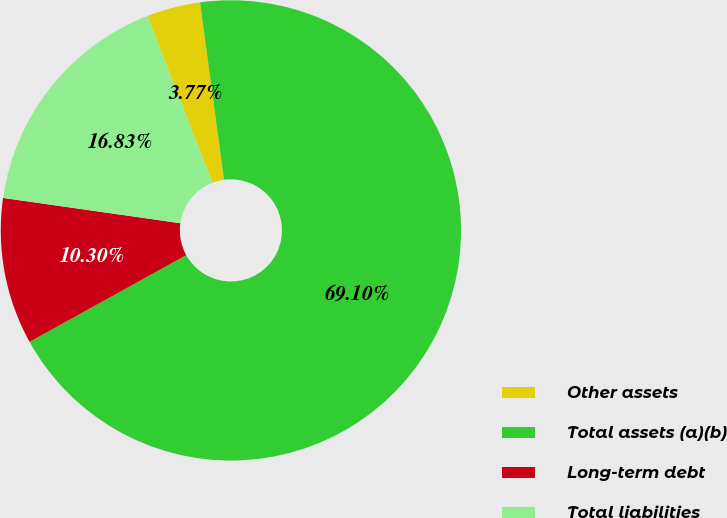Convert chart. <chart><loc_0><loc_0><loc_500><loc_500><pie_chart><fcel>Other assets<fcel>Total assets (a)(b)<fcel>Long-term debt<fcel>Total liabilities<nl><fcel>3.77%<fcel>69.09%<fcel>10.3%<fcel>16.83%<nl></chart> 